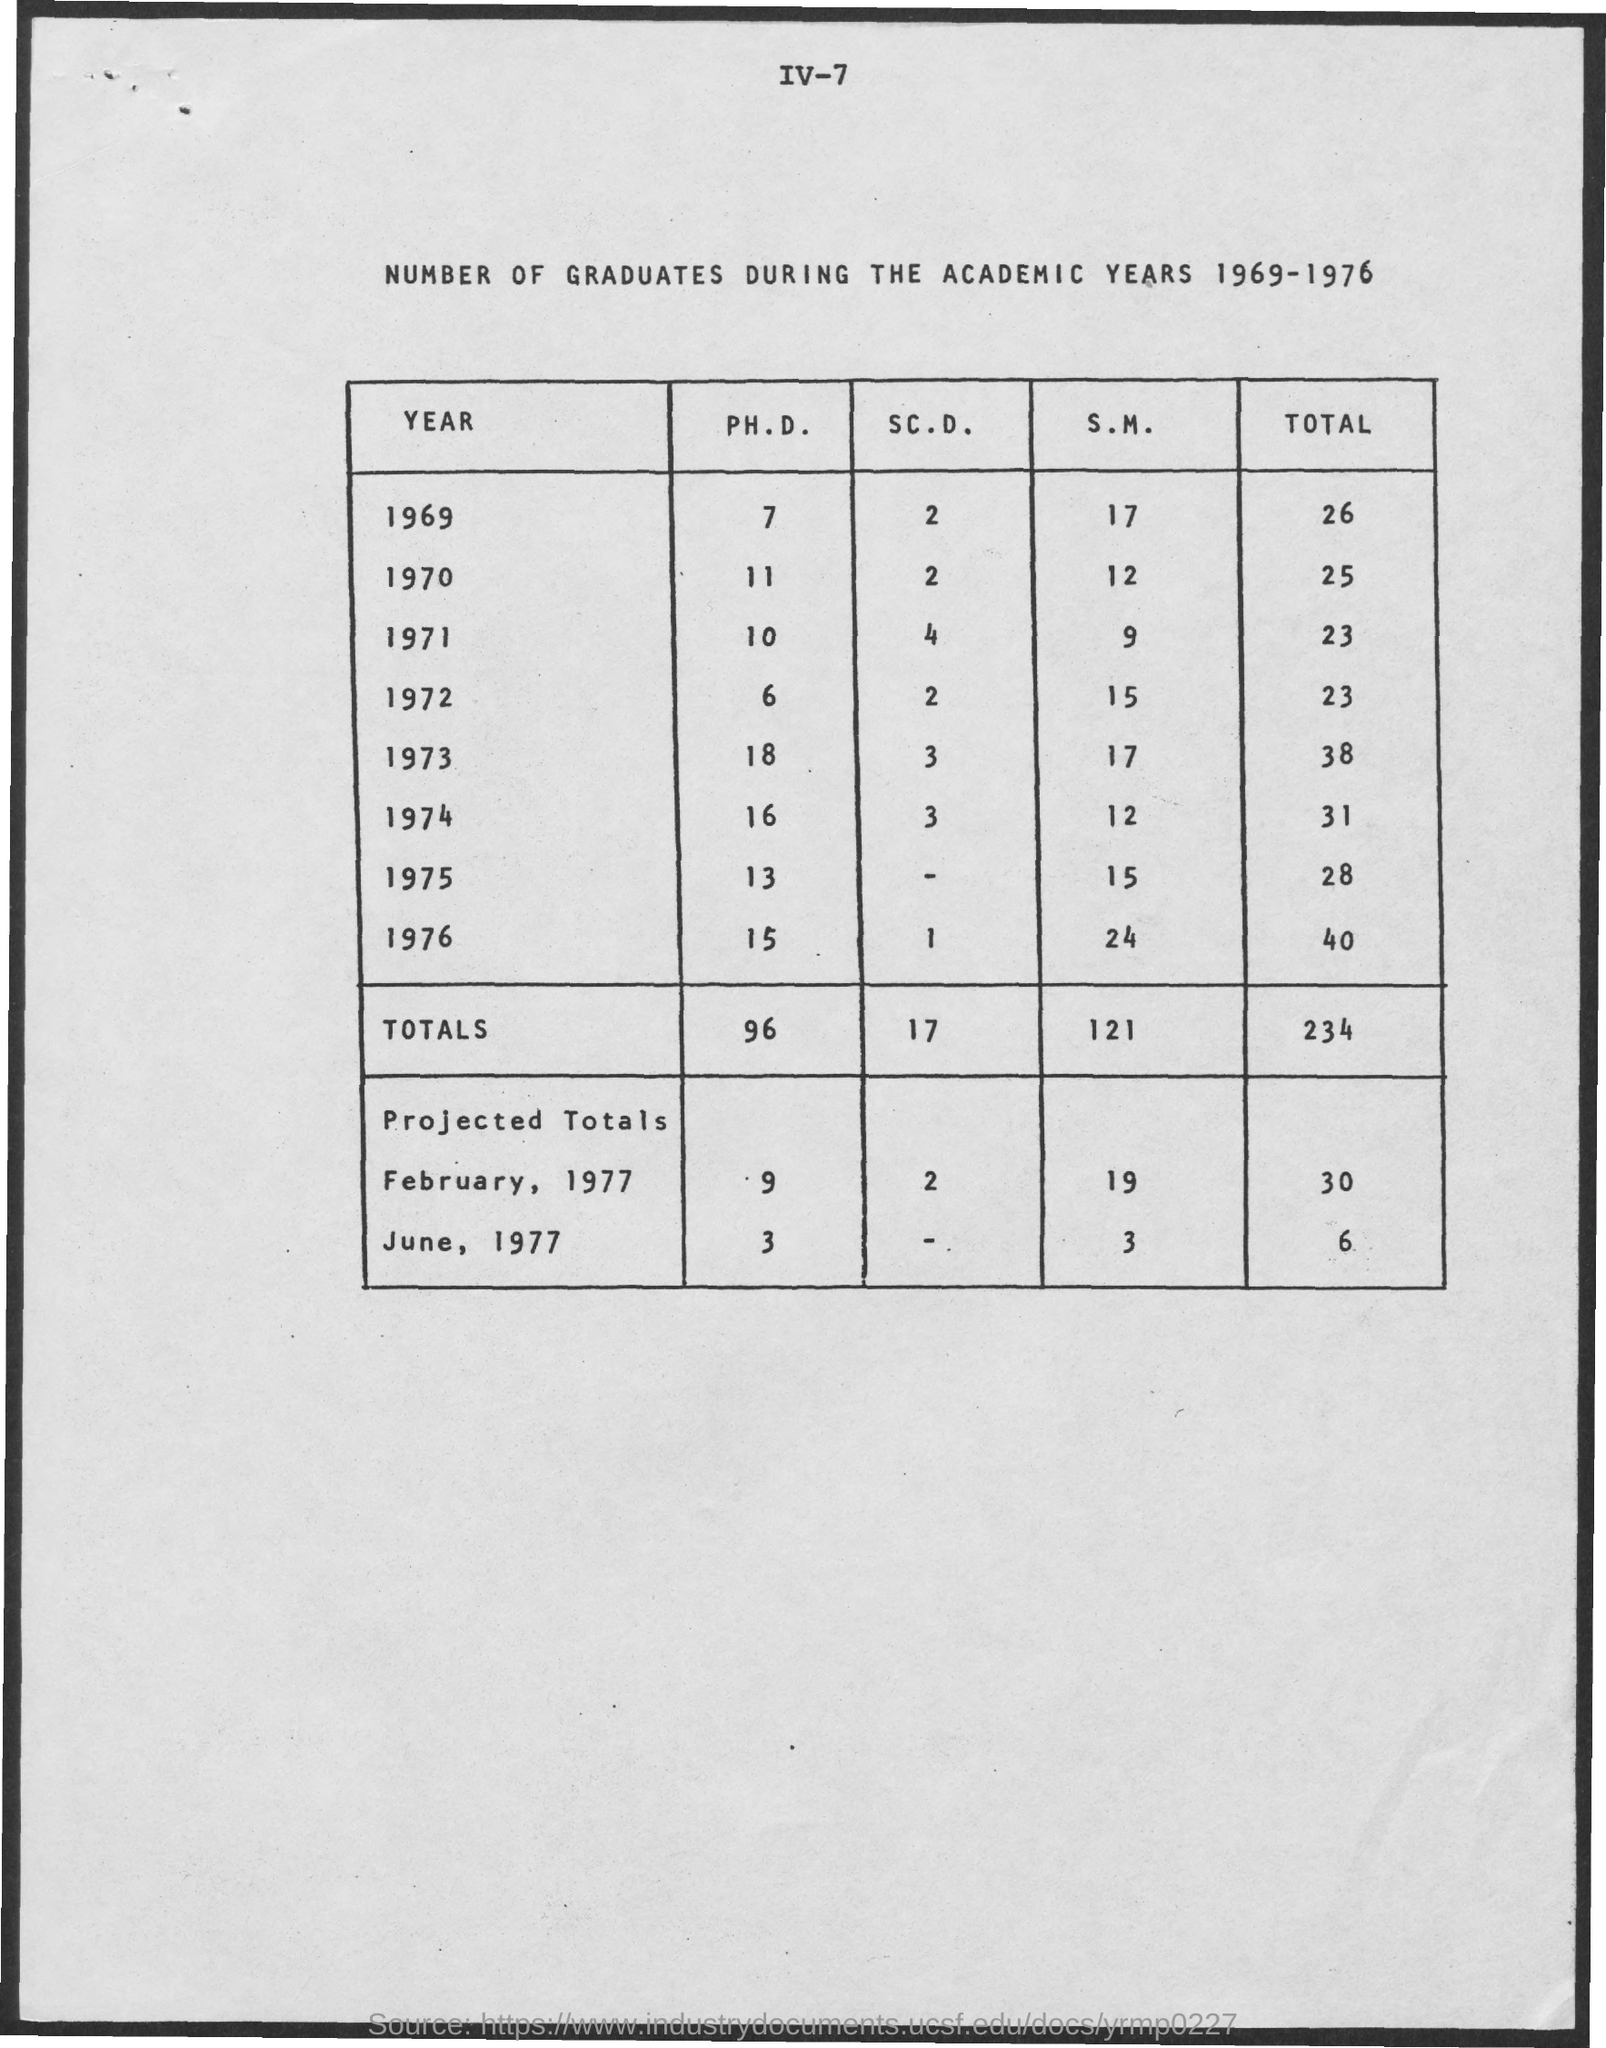Total of 40 is in which year?
Keep it short and to the point. 1976. 